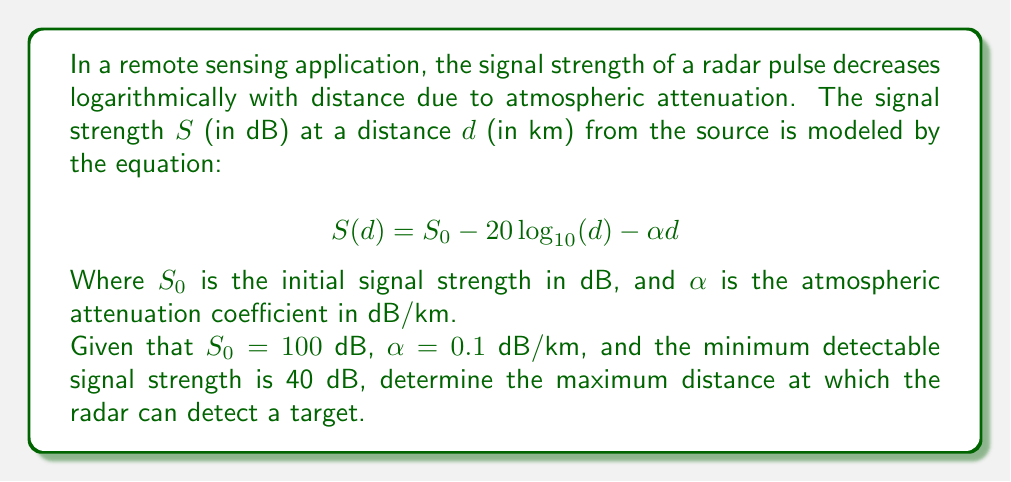Teach me how to tackle this problem. To solve this problem, we need to follow these steps:

1) First, we set up the equation with the given values:
   $$40 = 100 - 20 \log_{10}(d) - 0.1d$$

2) Rearrange the equation to isolate the logarithmic term:
   $$20 \log_{10}(d) = 60 - 0.1d$$

3) Divide both sides by 20:
   $$\log_{10}(d) = 3 - 0.005d$$

4) Apply the exponential function (base 10) to both sides:
   $$10^{\log_{10}(d)} = 10^{3 - 0.005d}$$

5) Simplify the left side:
   $$d = 10^{3 - 0.005d}$$

6) This equation cannot be solved algebraically due to the presence of $d$ on both sides. We need to use numerical methods or graphical solutions to find the value of $d$.

7) Using a numerical method (e.g., Newton-Raphson method) or a graphing calculator, we can find that the solution is approximately:
   $$d \approx 955.63 \text{ km}$$

This means the maximum distance at which the radar can detect a target is about 955.63 km.
Answer: The maximum detection distance is approximately 955.63 km. 